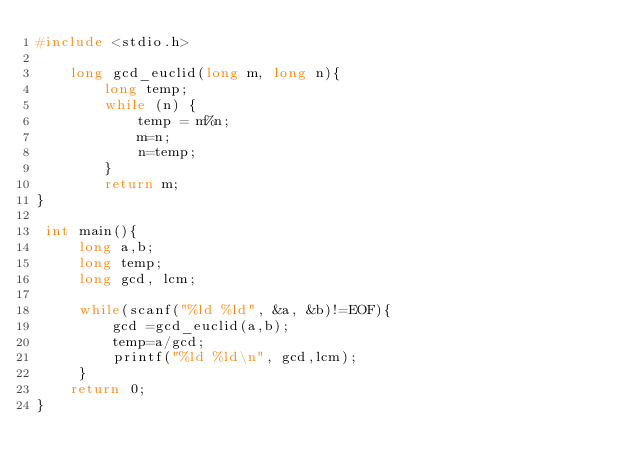Convert code to text. <code><loc_0><loc_0><loc_500><loc_500><_C_>#include <stdio.h>
 
    long gcd_euclid(long m, long n){
        long temp;
        while (n) {
            temp = m%n;
            m=n;
            n=temp;
        }
        return m;
}

 int main(){
     long a,b;
     long temp;
     long gcd, lcm;
     
     while(scanf("%ld %ld", &a, &b)!=EOF){
         gcd =gcd_euclid(a,b);
         temp=a/gcd;
         printf("%ld %ld\n", gcd,lcm);
     }
    return 0;
}
</code> 